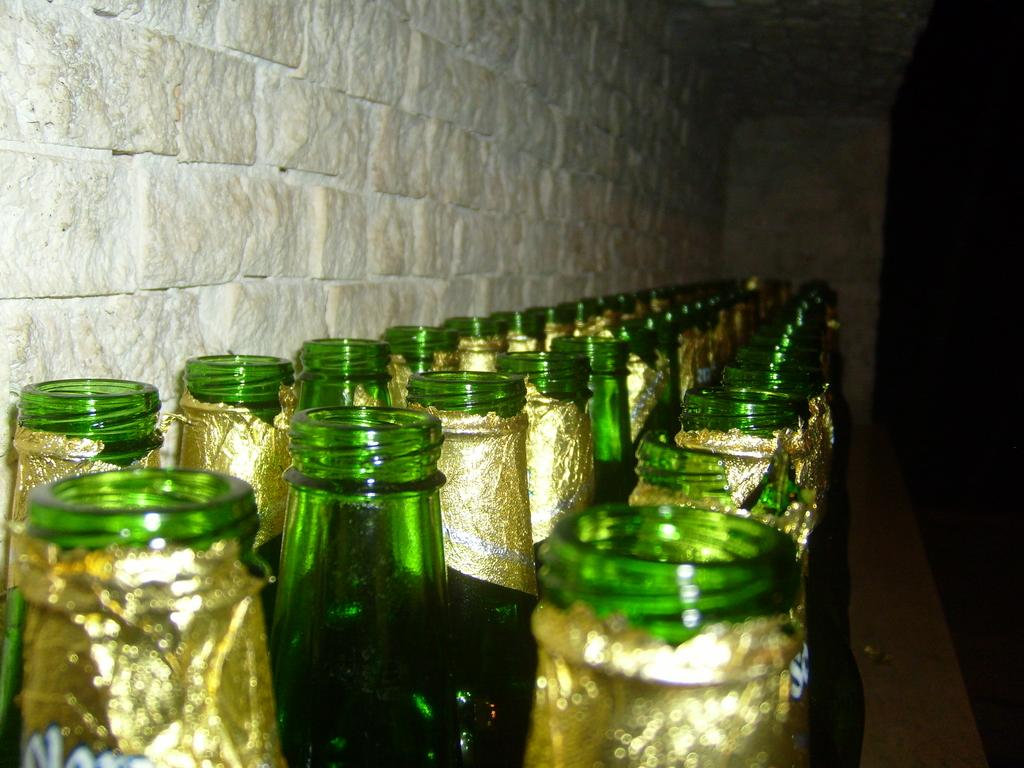What is the primary object featured in the image? There are many bottles in the image. What color are the bottles? The bottles are green in color. What is unique about the label on the bottles? The bottles have a golden label. How are the bottles arranged in the image? The bottles are arranged in three rows. What can be seen in the background of the image? There is a wall in the image. How does the muscle in the image appear to be affecting the temper of the bottles? There is no muscle or temper present in the image; it features bottles arranged in three rows with a golden label and a green color. 